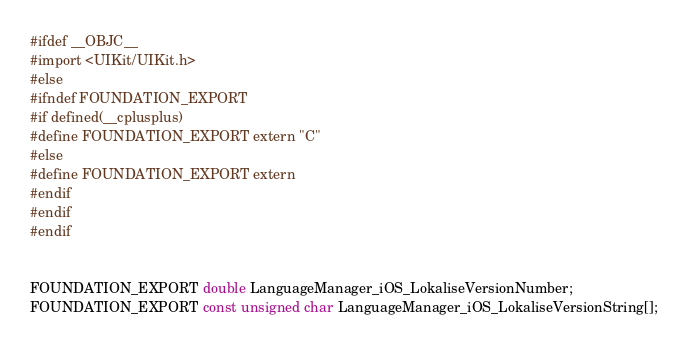<code> <loc_0><loc_0><loc_500><loc_500><_C_>#ifdef __OBJC__
#import <UIKit/UIKit.h>
#else
#ifndef FOUNDATION_EXPORT
#if defined(__cplusplus)
#define FOUNDATION_EXPORT extern "C"
#else
#define FOUNDATION_EXPORT extern
#endif
#endif
#endif


FOUNDATION_EXPORT double LanguageManager_iOS_LokaliseVersionNumber;
FOUNDATION_EXPORT const unsigned char LanguageManager_iOS_LokaliseVersionString[];

</code> 